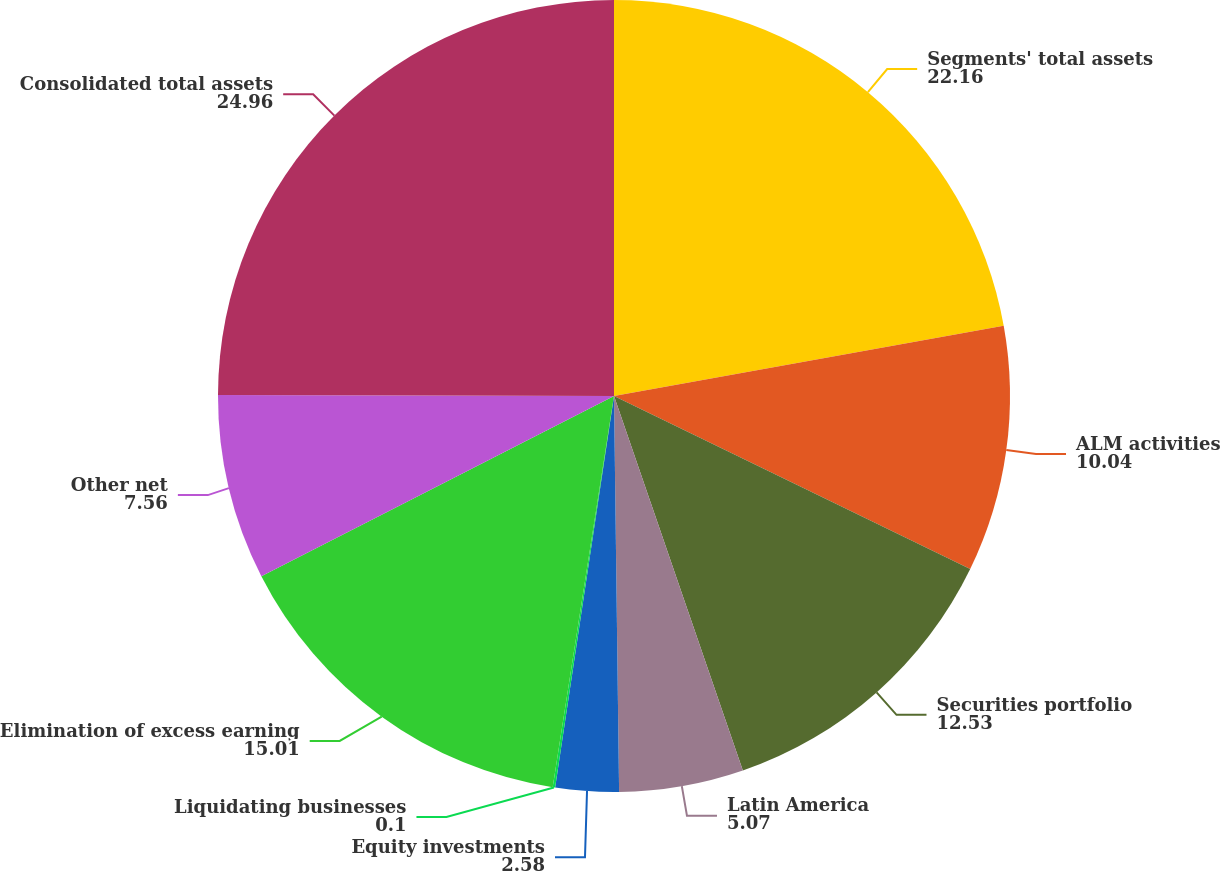Convert chart. <chart><loc_0><loc_0><loc_500><loc_500><pie_chart><fcel>Segments' total assets<fcel>ALM activities<fcel>Securities portfolio<fcel>Latin America<fcel>Equity investments<fcel>Liquidating businesses<fcel>Elimination of excess earning<fcel>Other net<fcel>Consolidated total assets<nl><fcel>22.16%<fcel>10.04%<fcel>12.53%<fcel>5.07%<fcel>2.58%<fcel>0.1%<fcel>15.01%<fcel>7.56%<fcel>24.96%<nl></chart> 